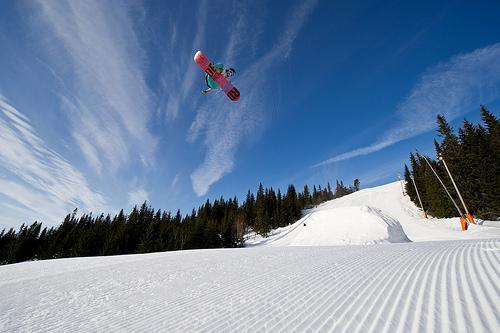How many snowboards are there?
Give a very brief answer. 1. 